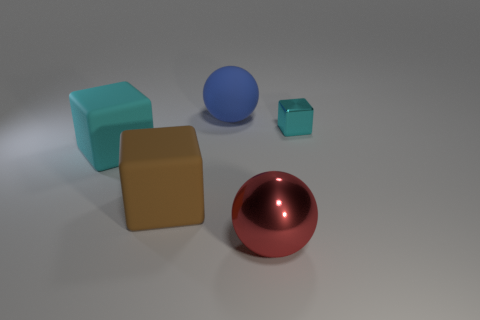Is there any other thing that is the same size as the cyan metal object?
Give a very brief answer. No. The shiny object that is in front of the cyan block that is to the left of the cyan block on the right side of the big cyan block is what color?
Give a very brief answer. Red. Is the rubber sphere the same color as the metallic ball?
Your answer should be compact. No. How many things are both in front of the large cyan object and on the right side of the large brown thing?
Ensure brevity in your answer.  1. What number of shiny things are either big blue objects or brown things?
Make the answer very short. 0. What material is the large sphere behind the metal object behind the big brown rubber object?
Provide a succinct answer. Rubber. There is a rubber thing that is the same color as the tiny shiny thing; what is its shape?
Keep it short and to the point. Cube. There is a brown matte object that is the same size as the red metal object; what shape is it?
Your answer should be very brief. Cube. Are there fewer brown matte things than tiny red metal objects?
Your response must be concise. No. Are there any big cyan cubes that are right of the cyan object to the right of the large blue object?
Your response must be concise. No. 